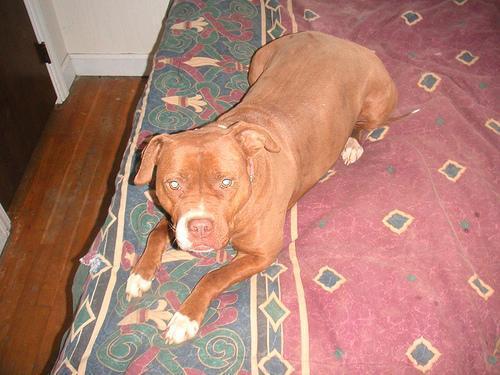How many people are wearing bright yellow?
Give a very brief answer. 0. 